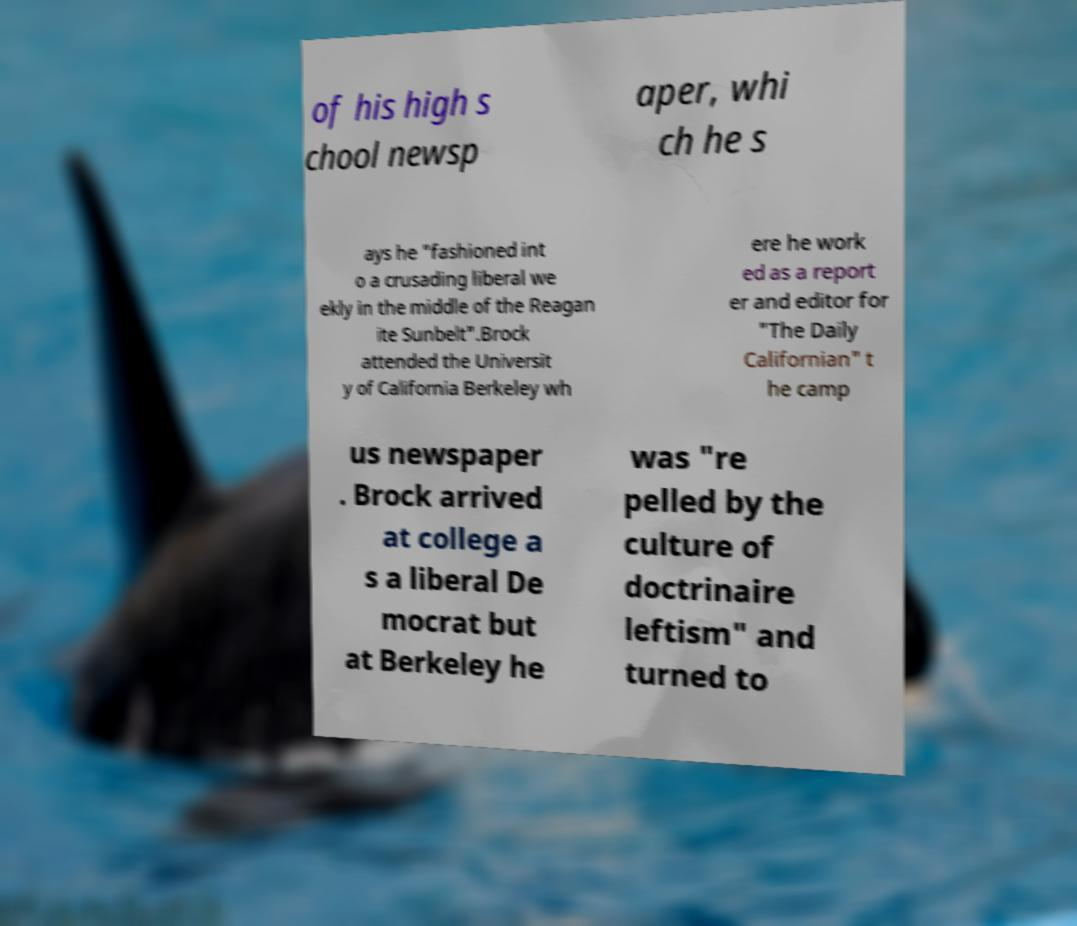I need the written content from this picture converted into text. Can you do that? of his high s chool newsp aper, whi ch he s ays he "fashioned int o a crusading liberal we ekly in the middle of the Reagan ite Sunbelt".Brock attended the Universit y of California Berkeley wh ere he work ed as a report er and editor for "The Daily Californian" t he camp us newspaper . Brock arrived at college a s a liberal De mocrat but at Berkeley he was "re pelled by the culture of doctrinaire leftism" and turned to 